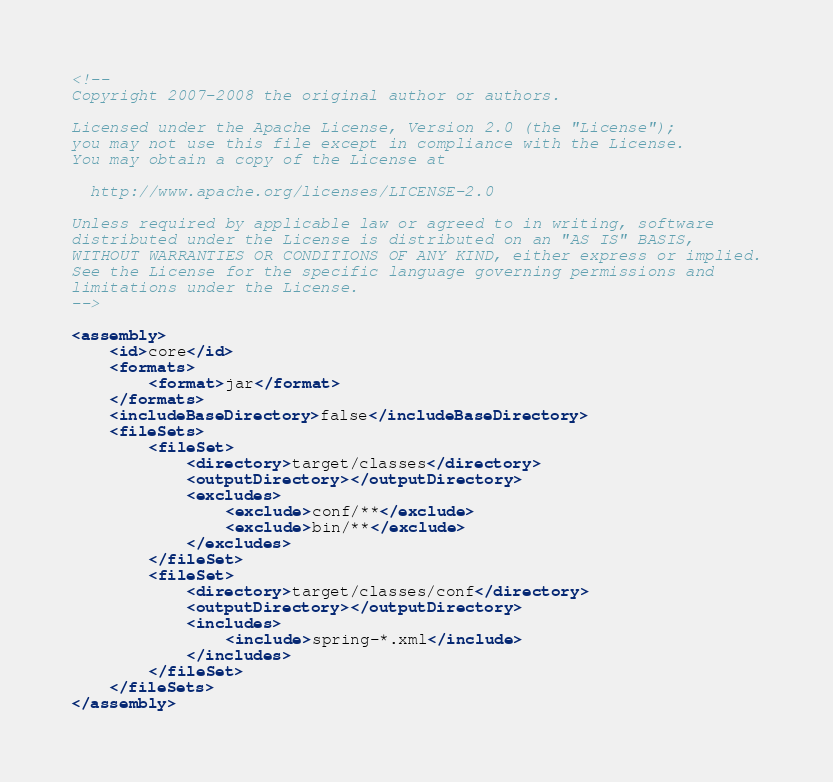Convert code to text. <code><loc_0><loc_0><loc_500><loc_500><_XML_><!--
Copyright 2007-2008 the original author or authors.

Licensed under the Apache License, Version 2.0 (the "License");
you may not use this file except in compliance with the License.
You may obtain a copy of the License at

  http://www.apache.org/licenses/LICENSE-2.0

Unless required by applicable law or agreed to in writing, software
distributed under the License is distributed on an "AS IS" BASIS,
WITHOUT WARRANTIES OR CONDITIONS OF ANY KIND, either express or implied.
See the License for the specific language governing permissions and
limitations under the License.
-->

<assembly>
	<id>core</id>
	<formats>
		<format>jar</format>
	</formats>
	<includeBaseDirectory>false</includeBaseDirectory>
	<fileSets>
		<fileSet>
			<directory>target/classes</directory>
			<outputDirectory></outputDirectory>
			<excludes>
				<exclude>conf/**</exclude>
				<exclude>bin/**</exclude>
			</excludes>
		</fileSet>
		<fileSet>
			<directory>target/classes/conf</directory>
			<outputDirectory></outputDirectory>
			<includes>
				<include>spring-*.xml</include>
			</includes>
		</fileSet>
	</fileSets>
</assembly>
</code> 